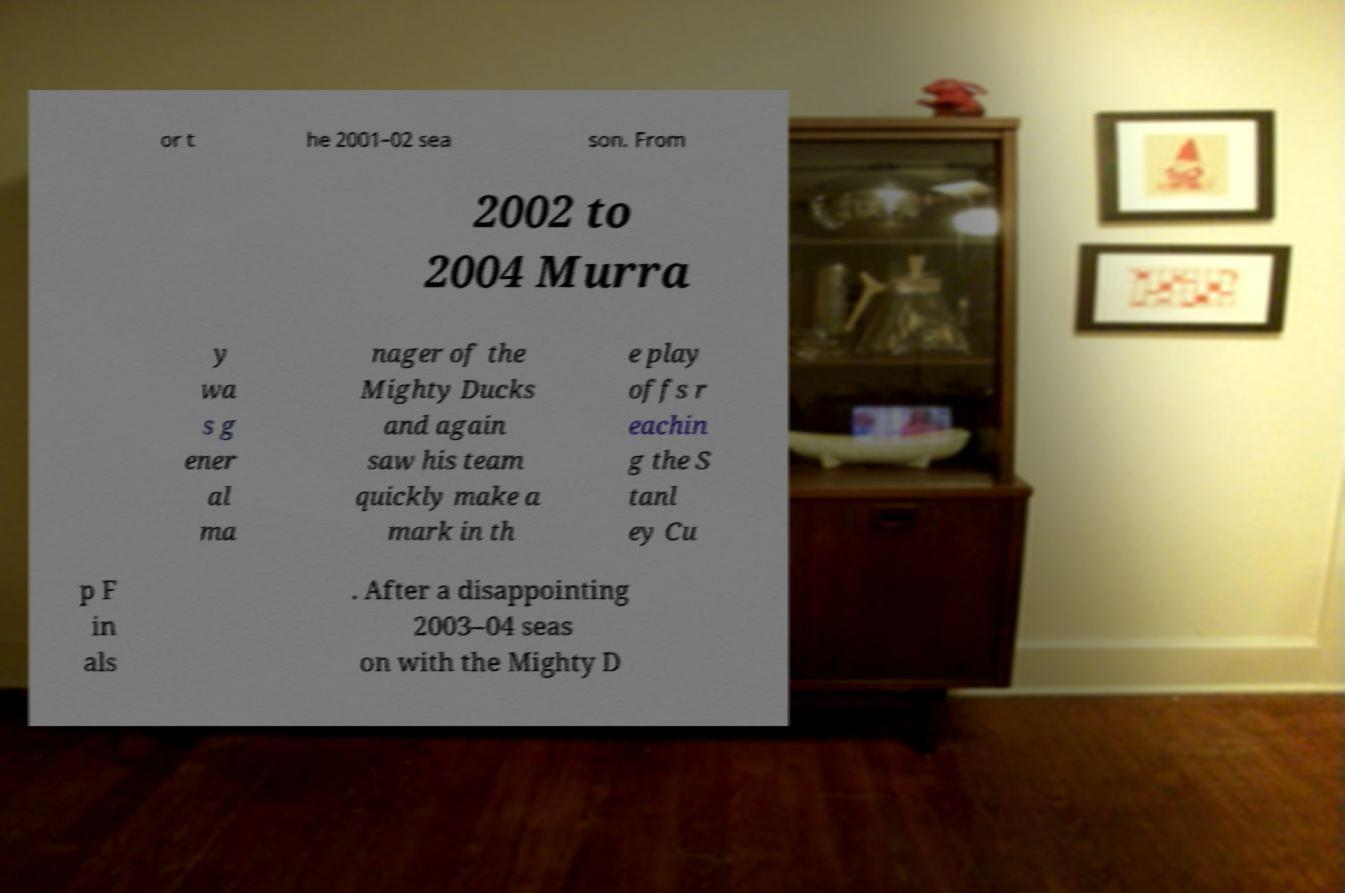Could you extract and type out the text from this image? or t he 2001–02 sea son. From 2002 to 2004 Murra y wa s g ener al ma nager of the Mighty Ducks and again saw his team quickly make a mark in th e play offs r eachin g the S tanl ey Cu p F in als . After a disappointing 2003–04 seas on with the Mighty D 